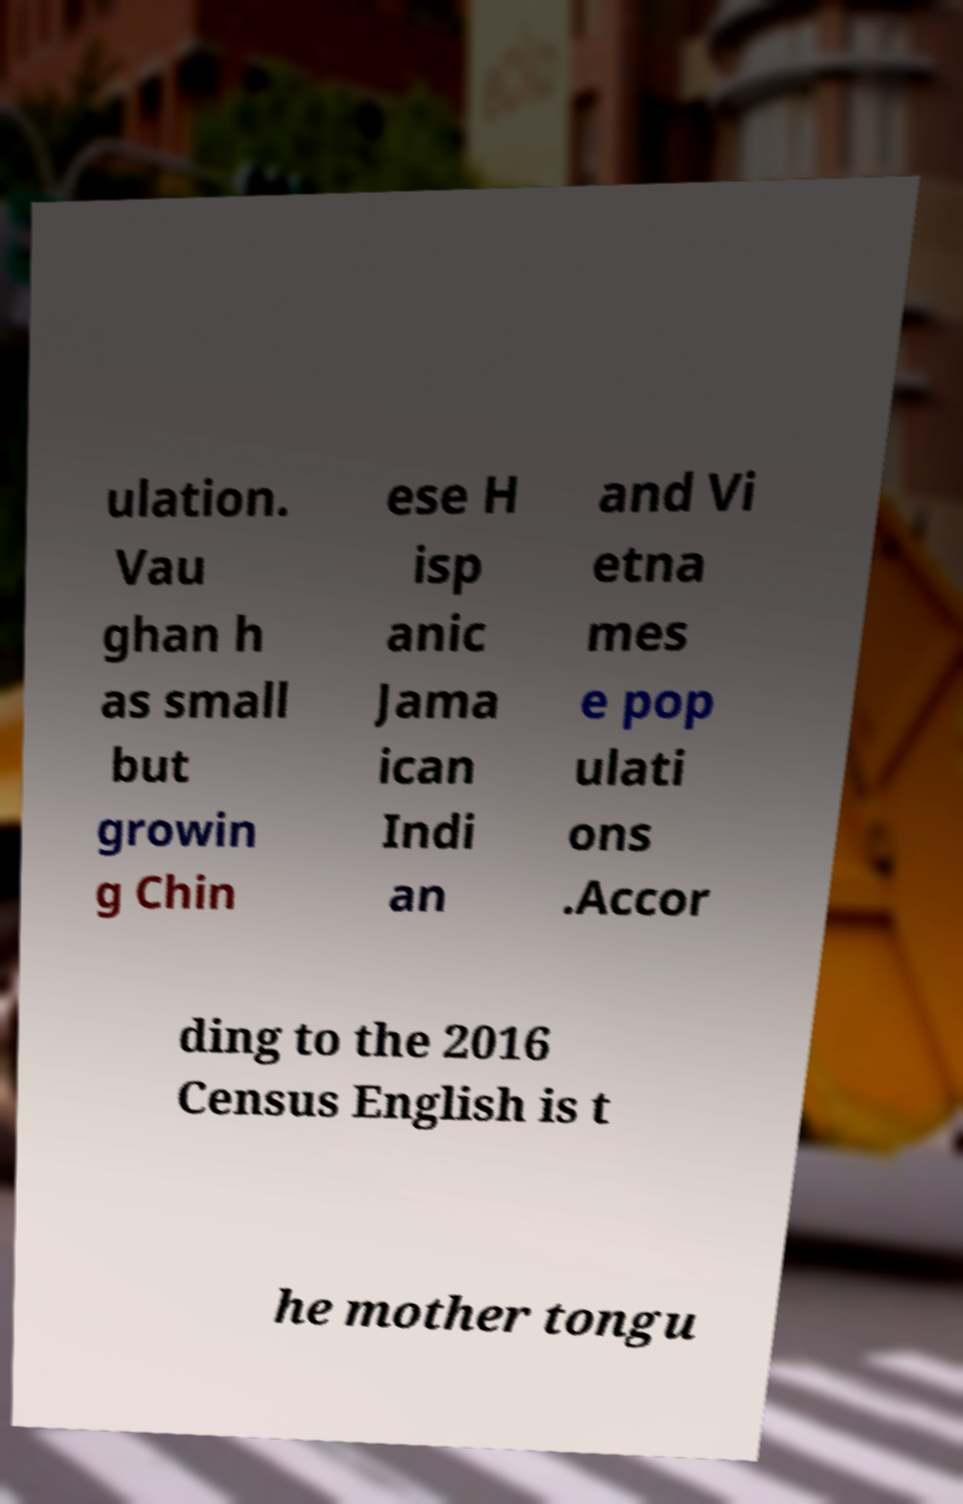I need the written content from this picture converted into text. Can you do that? ulation. Vau ghan h as small but growin g Chin ese H isp anic Jama ican Indi an and Vi etna mes e pop ulati ons .Accor ding to the 2016 Census English is t he mother tongu 